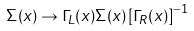<formula> <loc_0><loc_0><loc_500><loc_500>\Sigma ( x ) \to \Gamma _ { L } ( x ) \Sigma ( x ) \left [ \Gamma _ { R } ( x ) \right ] ^ { - 1 }</formula> 